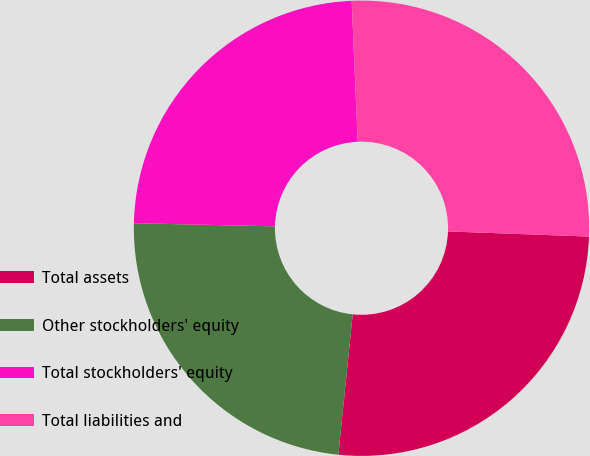<chart> <loc_0><loc_0><loc_500><loc_500><pie_chart><fcel>Total assets<fcel>Other stockholders' equity<fcel>Total stockholders' equity<fcel>Total liabilities and<nl><fcel>26.04%<fcel>23.73%<fcel>23.96%<fcel>26.27%<nl></chart> 